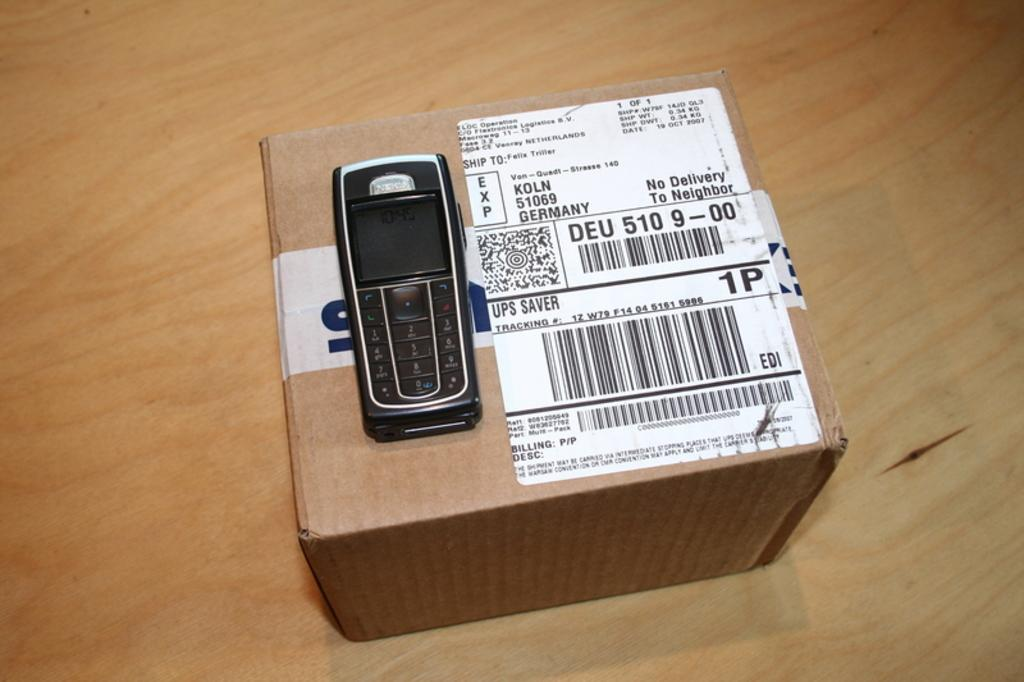<image>
Create a compact narrative representing the image presented. A black Nokia cellphone sitting atop an unopened mail parcel. 